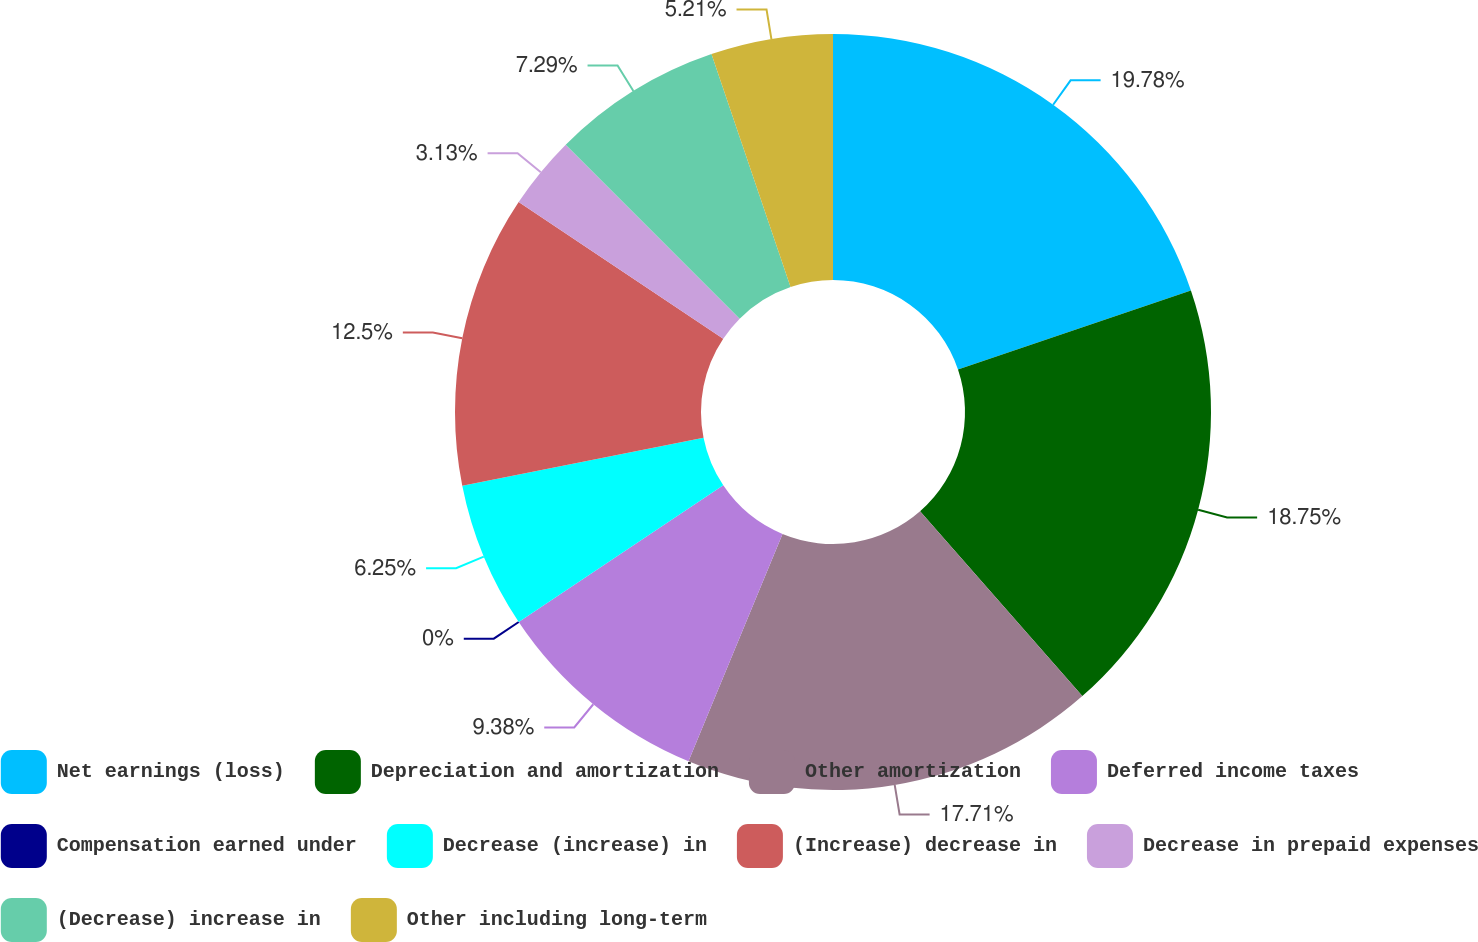Convert chart. <chart><loc_0><loc_0><loc_500><loc_500><pie_chart><fcel>Net earnings (loss)<fcel>Depreciation and amortization<fcel>Other amortization<fcel>Deferred income taxes<fcel>Compensation earned under<fcel>Decrease (increase) in<fcel>(Increase) decrease in<fcel>Decrease in prepaid expenses<fcel>(Decrease) increase in<fcel>Other including long-term<nl><fcel>19.79%<fcel>18.75%<fcel>17.71%<fcel>9.38%<fcel>0.0%<fcel>6.25%<fcel>12.5%<fcel>3.13%<fcel>7.29%<fcel>5.21%<nl></chart> 